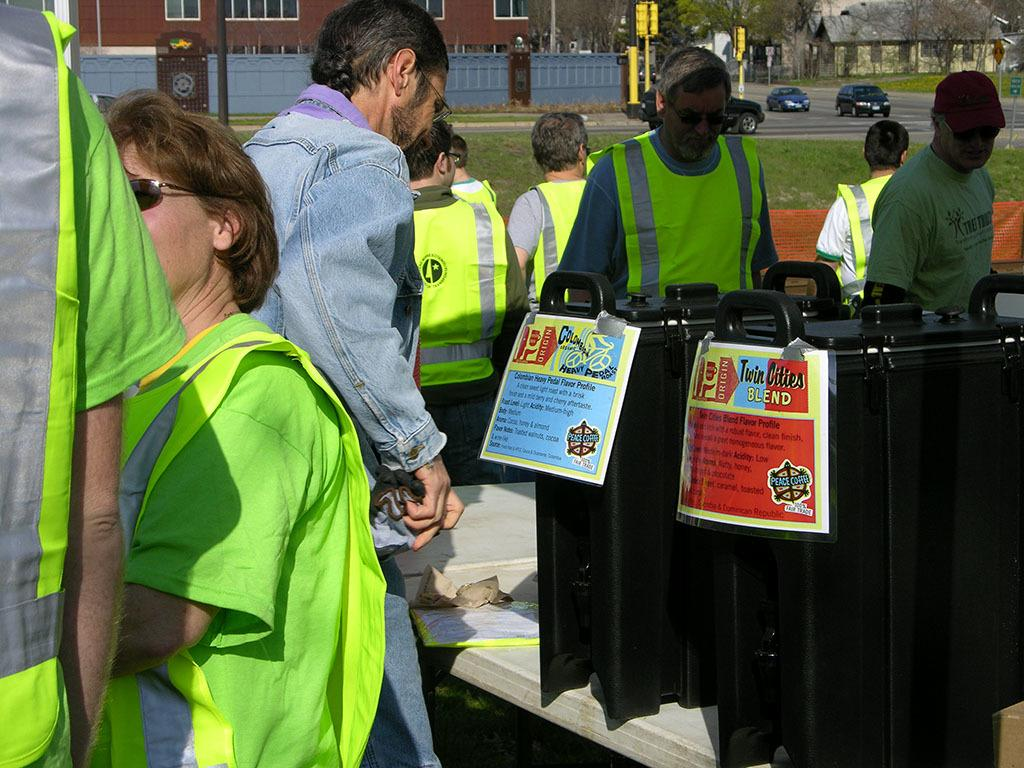Provide a one-sentence caption for the provided image. A group where a man is reading a sign from Twin Cities Blend. 